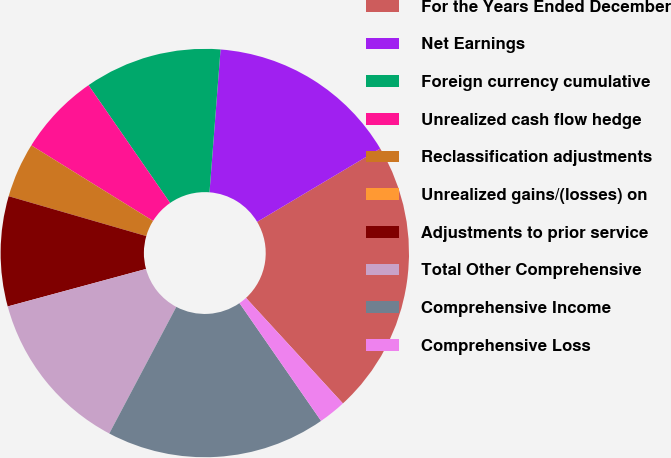<chart> <loc_0><loc_0><loc_500><loc_500><pie_chart><fcel>For the Years Ended December<fcel>Net Earnings<fcel>Foreign currency cumulative<fcel>Unrealized cash flow hedge<fcel>Reclassification adjustments<fcel>Unrealized gains/(losses) on<fcel>Adjustments to prior service<fcel>Total Other Comprehensive<fcel>Comprehensive Income<fcel>Comprehensive Loss<nl><fcel>21.73%<fcel>15.22%<fcel>10.87%<fcel>6.52%<fcel>4.35%<fcel>0.0%<fcel>8.7%<fcel>13.04%<fcel>17.39%<fcel>2.18%<nl></chart> 